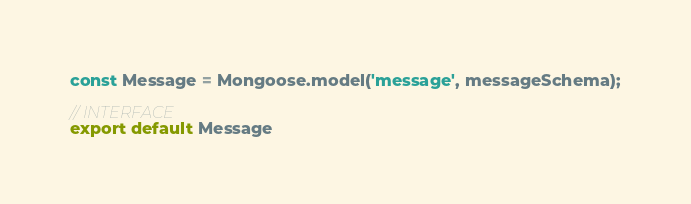Convert code to text. <code><loc_0><loc_0><loc_500><loc_500><_JavaScript_>const Message = Mongoose.model('message', messageSchema);

// INTERFACE
export default Message</code> 